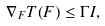Convert formula to latex. <formula><loc_0><loc_0><loc_500><loc_500>\nabla _ { F } T ( F ) \leq \Gamma I ,</formula> 